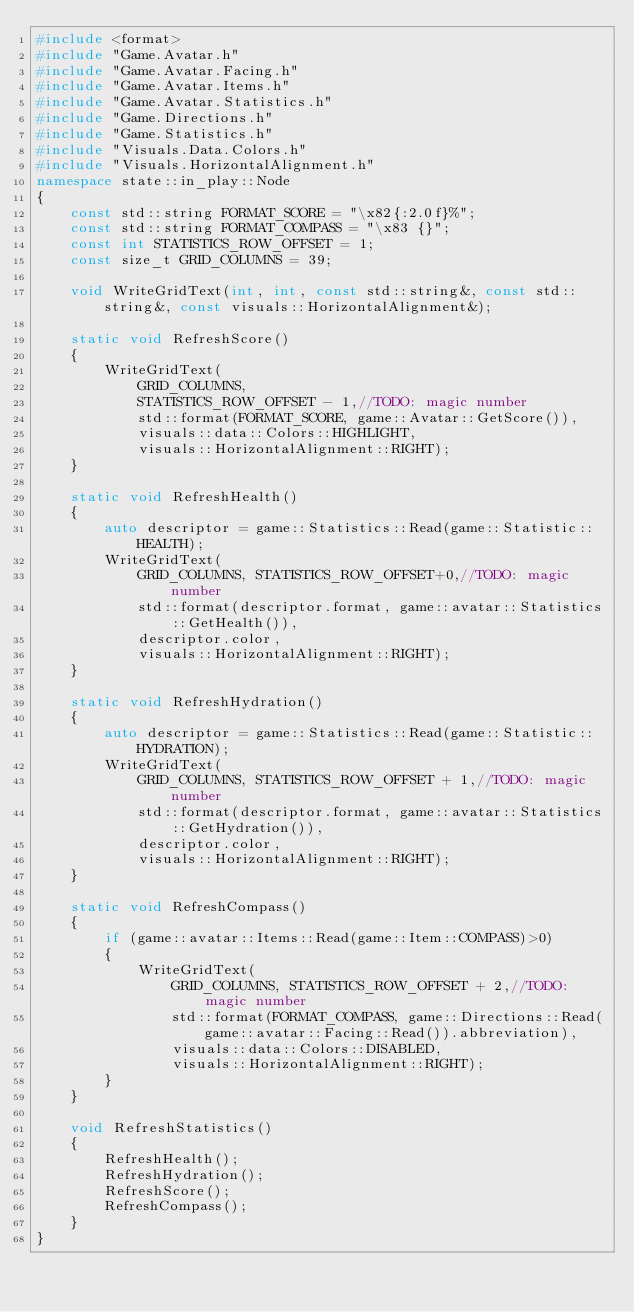<code> <loc_0><loc_0><loc_500><loc_500><_C++_>#include <format>
#include "Game.Avatar.h"
#include "Game.Avatar.Facing.h"
#include "Game.Avatar.Items.h"
#include "Game.Avatar.Statistics.h"
#include "Game.Directions.h"
#include "Game.Statistics.h"
#include "Visuals.Data.Colors.h"
#include "Visuals.HorizontalAlignment.h"
namespace state::in_play::Node
{
	const std::string FORMAT_SCORE = "\x82{:2.0f}%";
	const std::string FORMAT_COMPASS = "\x83 {}";
	const int STATISTICS_ROW_OFFSET = 1;
	const size_t GRID_COLUMNS = 39;

	void WriteGridText(int, int, const std::string&, const std::string&, const visuals::HorizontalAlignment&);

	static void RefreshScore()
	{
		WriteGridText(
			GRID_COLUMNS,
			STATISTICS_ROW_OFFSET - 1,//TODO: magic number
			std::format(FORMAT_SCORE, game::Avatar::GetScore()),
			visuals::data::Colors::HIGHLIGHT,
			visuals::HorizontalAlignment::RIGHT);
	}

	static void RefreshHealth()
	{
		auto descriptor = game::Statistics::Read(game::Statistic::HEALTH);
		WriteGridText(
			GRID_COLUMNS, STATISTICS_ROW_OFFSET+0,//TODO: magic number
			std::format(descriptor.format, game::avatar::Statistics::GetHealth()),
			descriptor.color,
			visuals::HorizontalAlignment::RIGHT);
	}

	static void RefreshHydration()
	{
		auto descriptor = game::Statistics::Read(game::Statistic::HYDRATION);
		WriteGridText(
			GRID_COLUMNS, STATISTICS_ROW_OFFSET + 1,//TODO: magic number
			std::format(descriptor.format, game::avatar::Statistics::GetHydration()),
			descriptor.color,
			visuals::HorizontalAlignment::RIGHT);
	}

	static void RefreshCompass()
	{
		if (game::avatar::Items::Read(game::Item::COMPASS)>0)
		{
			WriteGridText(
				GRID_COLUMNS, STATISTICS_ROW_OFFSET + 2,//TODO: magic number
				std::format(FORMAT_COMPASS, game::Directions::Read(game::avatar::Facing::Read()).abbreviation),
				visuals::data::Colors::DISABLED,
				visuals::HorizontalAlignment::RIGHT);
		}
	}

	void RefreshStatistics()
	{
		RefreshHealth();
		RefreshHydration();
		RefreshScore();
		RefreshCompass();
	}
}</code> 